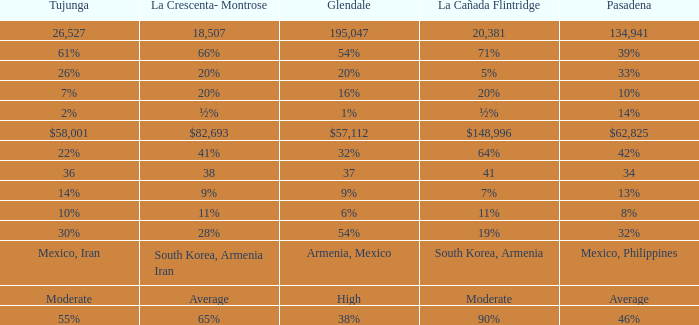Write the full table. {'header': ['Tujunga', 'La Crescenta- Montrose', 'Glendale', 'La Cañada Flintridge', 'Pasadena'], 'rows': [['26,527', '18,507', '195,047', '20,381', '134,941'], ['61%', '66%', '54%', '71%', '39%'], ['26%', '20%', '20%', '5%', '33%'], ['7%', '20%', '16%', '20%', '10%'], ['2%', '½%', '1%', '½%', '14%'], ['$58,001', '$82,693', '$57,112', '$148,996', '$62,825'], ['22%', '41%', '32%', '64%', '42%'], ['36', '38', '37', '41', '34'], ['14%', '9%', '9%', '7%', '13%'], ['10%', '11%', '6%', '11%', '8%'], ['30%', '28%', '54%', '19%', '32%'], ['Mexico, Iran', 'South Korea, Armenia Iran', 'Armenia, Mexico', 'South Korea, Armenia', 'Mexico, Philippines'], ['Moderate', 'Average', 'High', 'Moderate', 'Average'], ['55%', '65%', '38%', '90%', '46%']]} What proportion of glendale corresponds to la canada flintridge's 5%? 20%. 